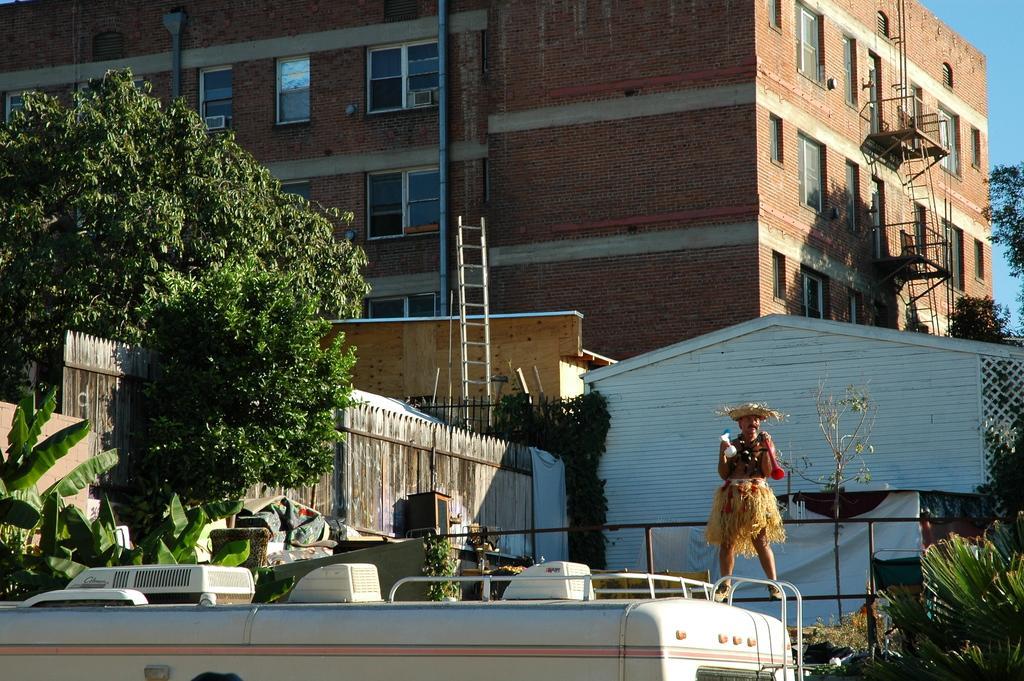How would you summarize this image in a sentence or two? In this image on the right, there is a man, standing on the vehicle. At the bottom there are trees, fence, vehicle, ladder. In the background there are buildings, wall, windows, glass, trees, ladder, sky. 